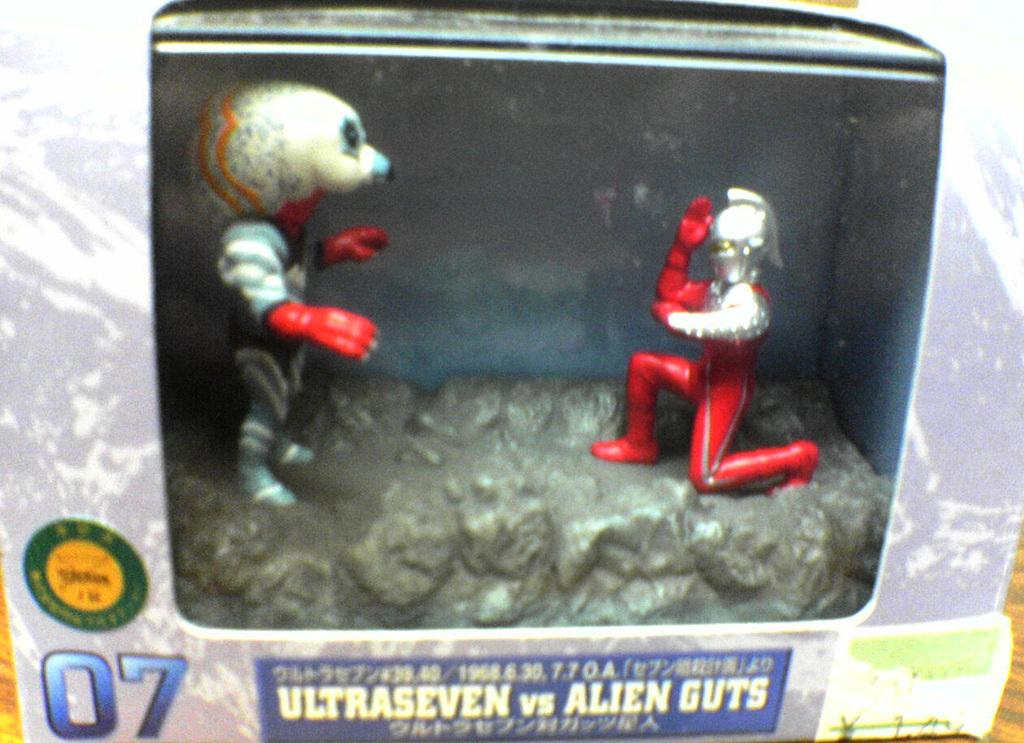What objects are present in the image? There are dolls in the image. Where are the dolls located? The dolls are kept in a box. Is there any text visible in the image? Yes, there is text at the bottom of the image. How many volleyballs can be seen in the image? There are no volleyballs present in the image. What is the relationship between the dolls and the sister mentioned in the image? There is no mention of a sister in the image, only dolls and text. 